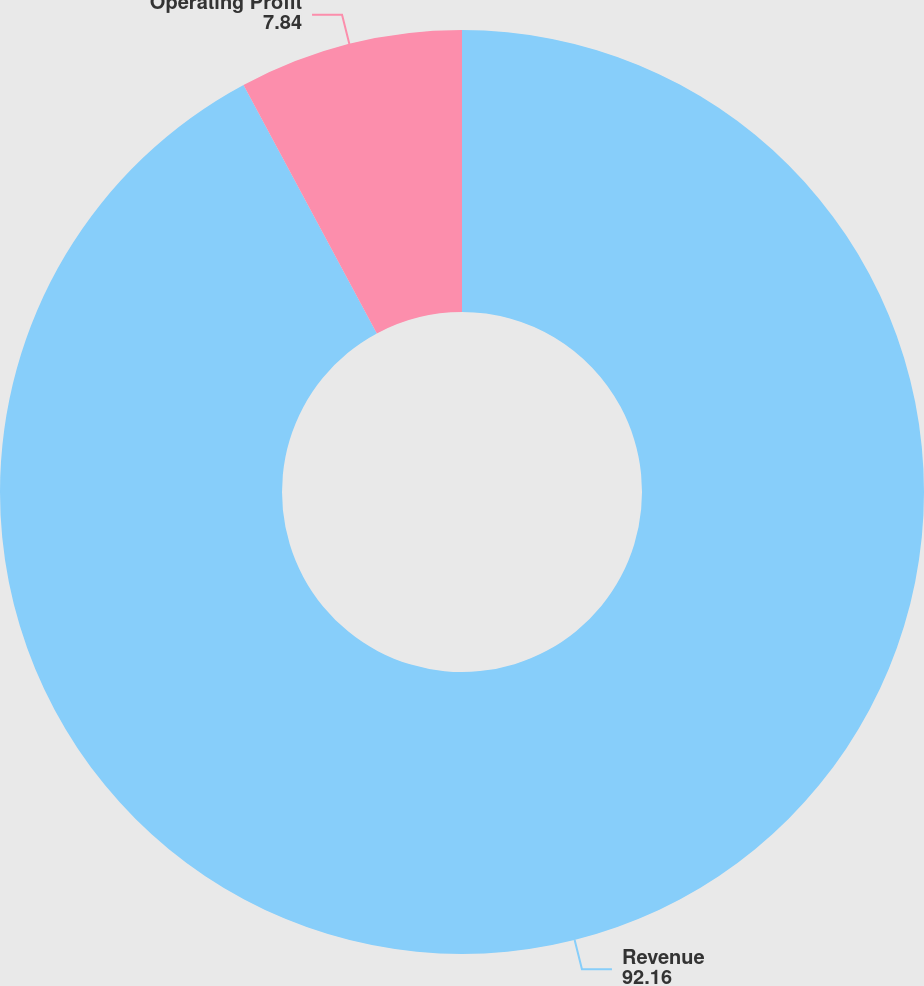<chart> <loc_0><loc_0><loc_500><loc_500><pie_chart><fcel>Revenue<fcel>Operating Profit<nl><fcel>92.16%<fcel>7.84%<nl></chart> 